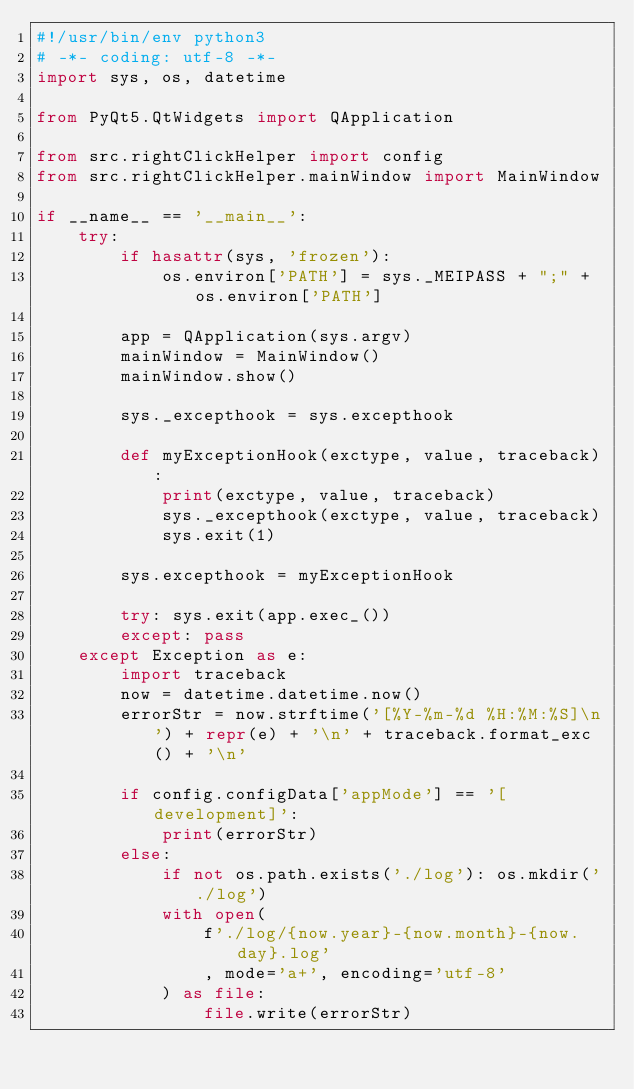<code> <loc_0><loc_0><loc_500><loc_500><_Python_>#!/usr/bin/env python3
# -*- coding: utf-8 -*-
import sys, os, datetime

from PyQt5.QtWidgets import QApplication

from src.rightClickHelper import config
from src.rightClickHelper.mainWindow import MainWindow

if __name__ == '__main__':
    try:
        if hasattr(sys, 'frozen'):
            os.environ['PATH'] = sys._MEIPASS + ";" + os.environ['PATH']

        app = QApplication(sys.argv)
        mainWindow = MainWindow()
        mainWindow.show()

        sys._excepthook = sys.excepthook

        def myExceptionHook(exctype, value, traceback):
            print(exctype, value, traceback)
            sys._excepthook(exctype, value, traceback)
            sys.exit(1)

        sys.excepthook = myExceptionHook

        try: sys.exit(app.exec_())
        except: pass
    except Exception as e:
        import traceback
        now = datetime.datetime.now()
        errorStr = now.strftime('[%Y-%m-%d %H:%M:%S]\n') + repr(e) + '\n' + traceback.format_exc() + '\n'

        if config.configData['appMode'] == '[development]':
            print(errorStr)
        else:
            if not os.path.exists('./log'): os.mkdir('./log')
            with open(
                f'./log/{now.year}-{now.month}-{now.day}.log'
                , mode='a+', encoding='utf-8'
            ) as file:
                file.write(errorStr)
</code> 